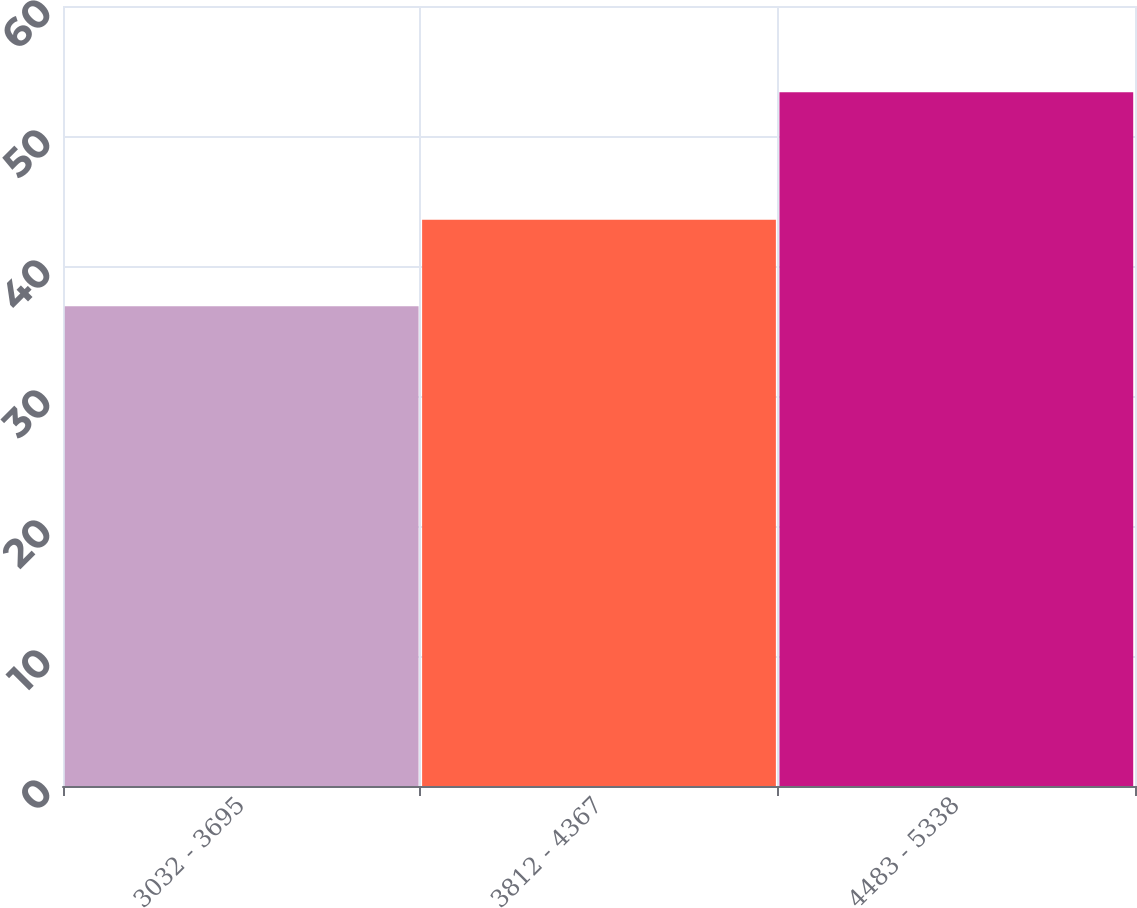Convert chart to OTSL. <chart><loc_0><loc_0><loc_500><loc_500><bar_chart><fcel>3032 - 3695<fcel>3812 - 4367<fcel>4483 - 5338<nl><fcel>36.91<fcel>43.55<fcel>53.36<nl></chart> 